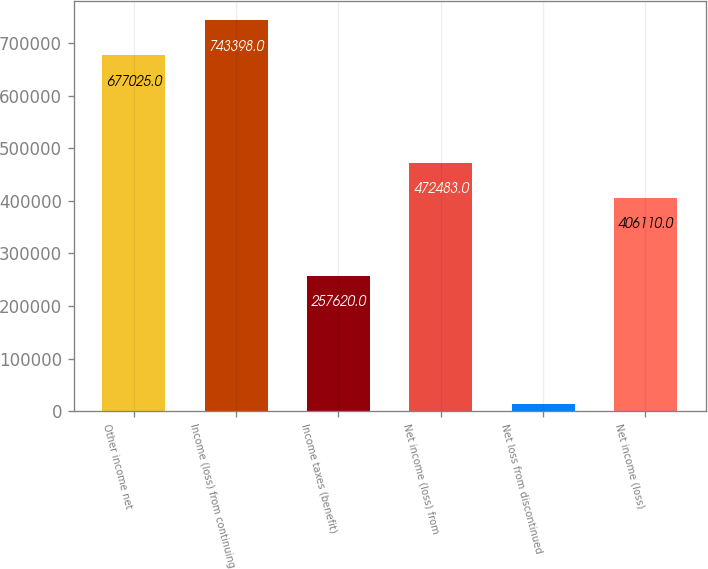Convert chart. <chart><loc_0><loc_0><loc_500><loc_500><bar_chart><fcel>Other income net<fcel>Income (loss) from continuing<fcel>Income taxes (benefit)<fcel>Net income (loss) from<fcel>Net loss from discontinued<fcel>Net income (loss)<nl><fcel>677025<fcel>743398<fcel>257620<fcel>472483<fcel>13295<fcel>406110<nl></chart> 